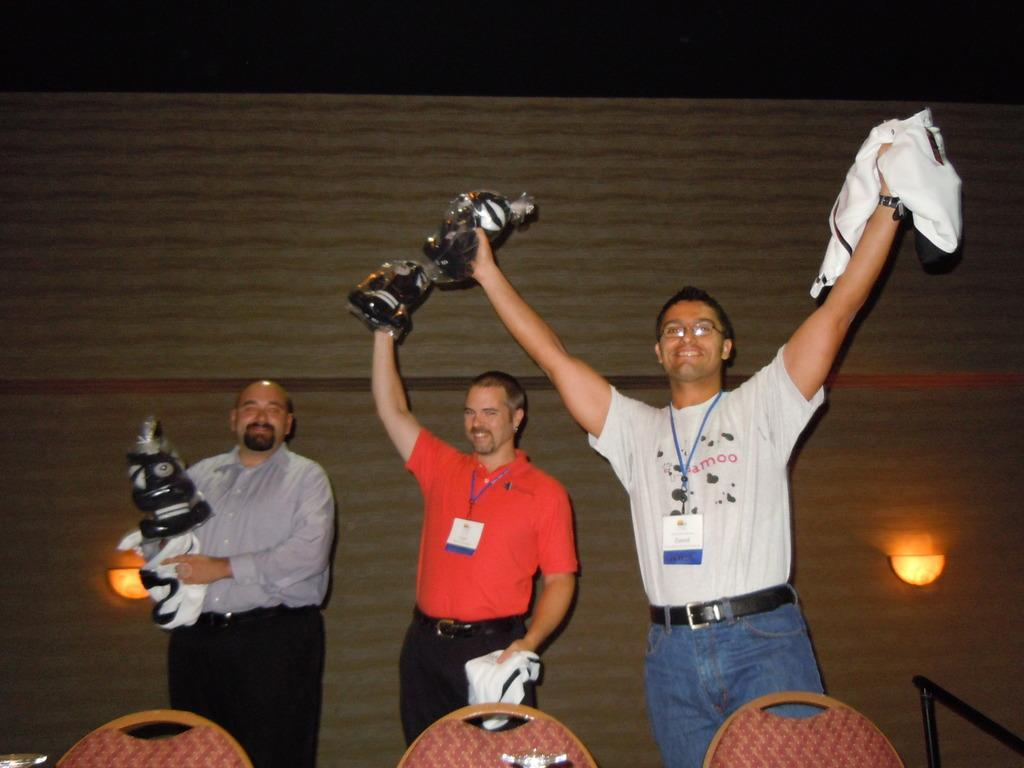How many people are in the image? There are three persons standing in the image. What are the persons holding in their hands? The persons are holding objects. What is in front of the persons? There are three chairs in front of the persons. What can be seen in the background of the image? There are lights visible in the background of the image. What type of father is depicted in the image? There is no father present in the image; it features three persons holding objects. What type of town is shown in the image? There is no town present in the image; it is an indoor setting with chairs, lights, and three persons holding objects. 